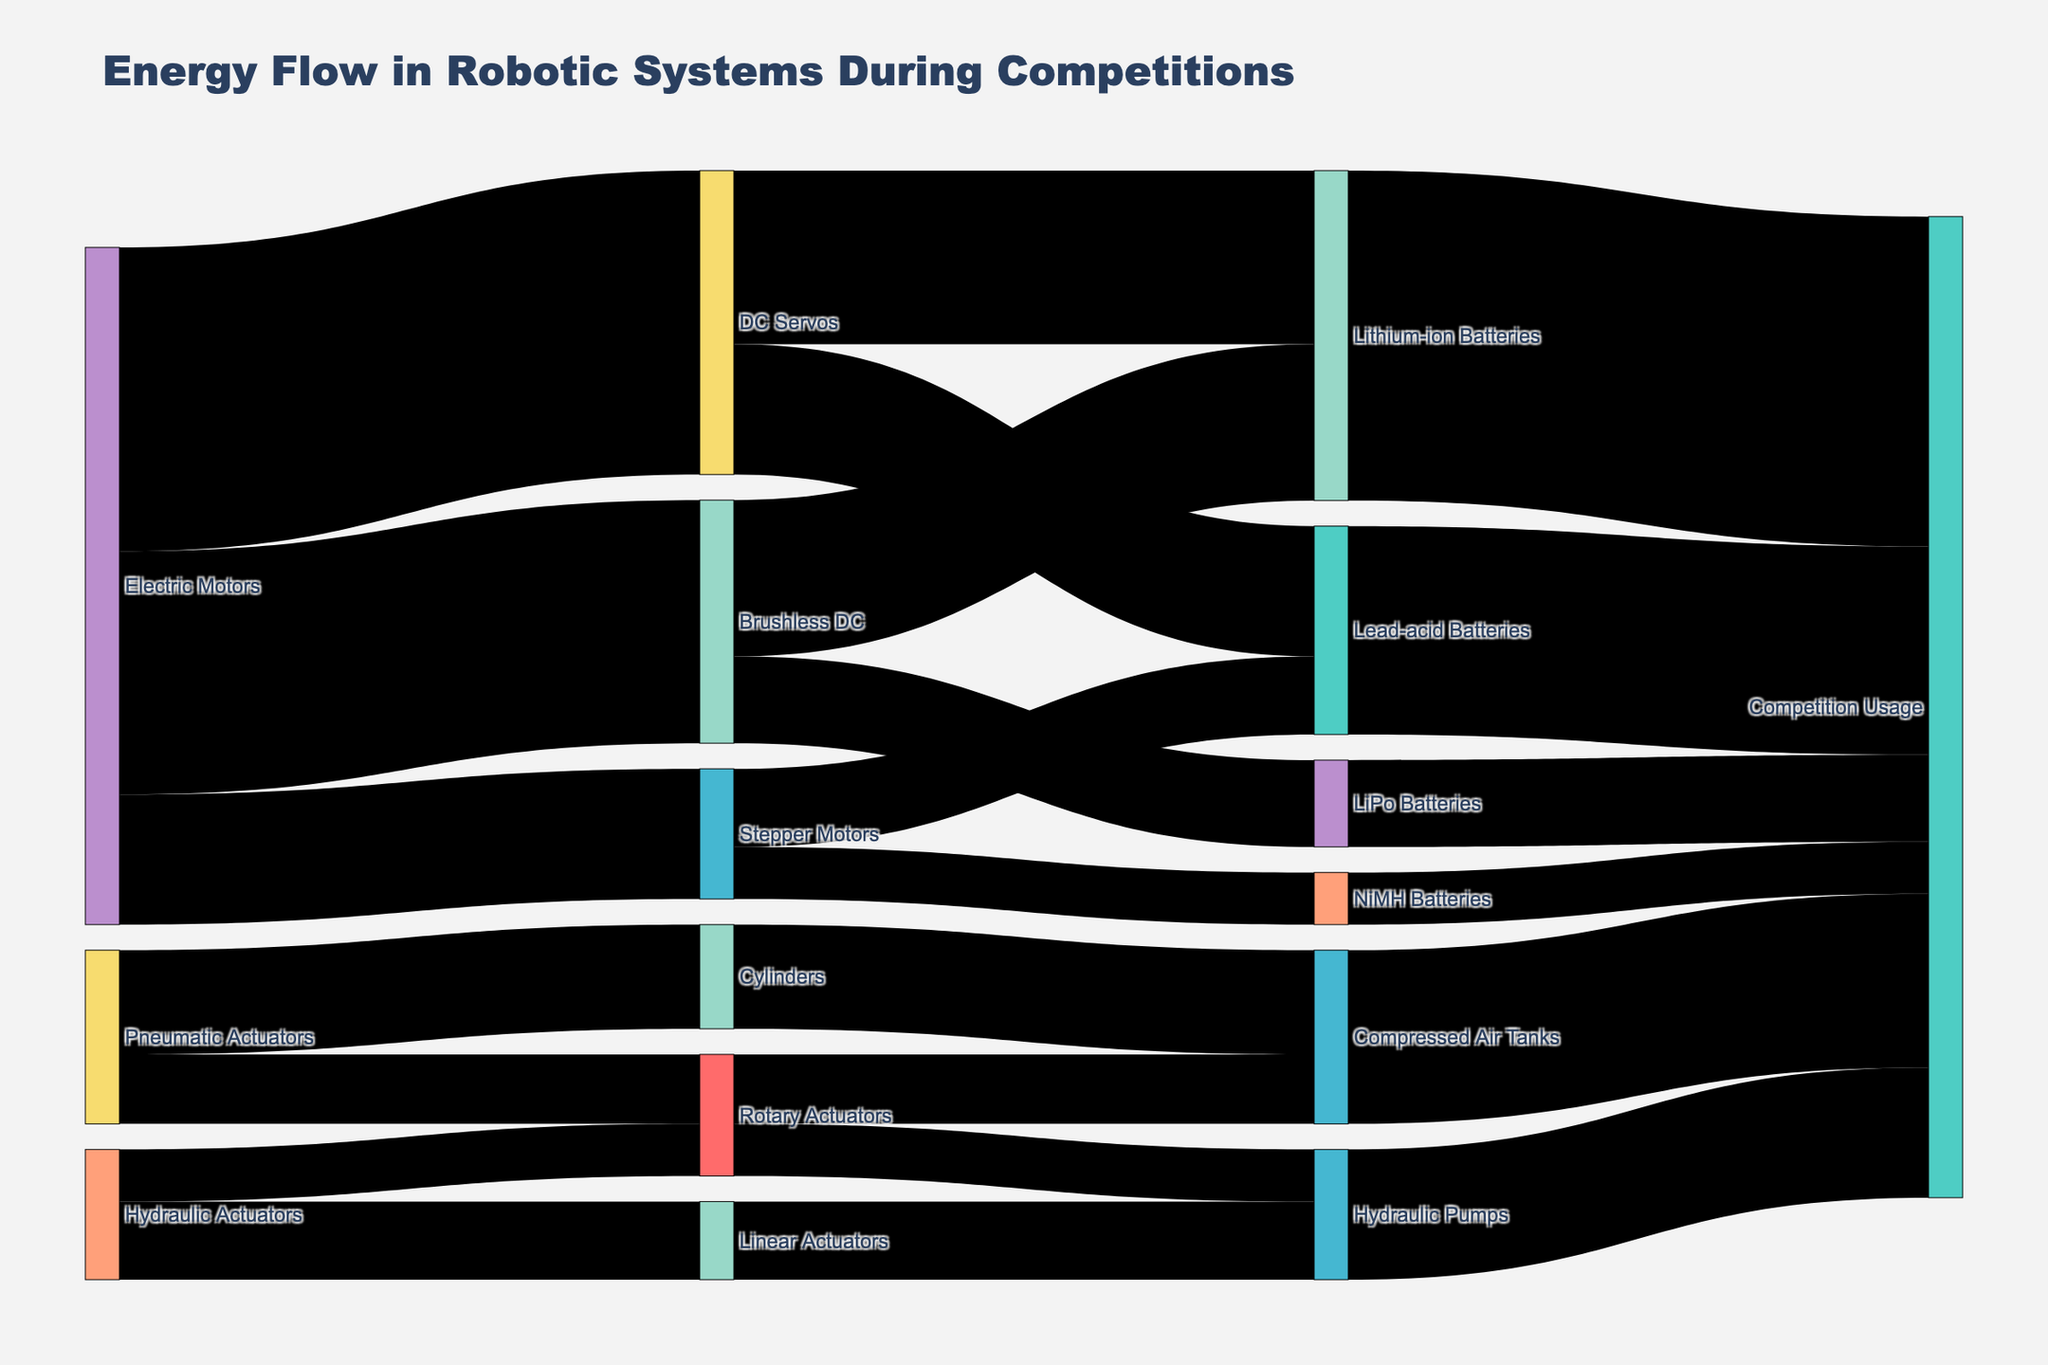what is the title of the figure? The title of the figure is found at the top of the diagram and describes the content. In this case, it reads, "Energy Flow in Robotic Systems During Competitions."
Answer: Energy Flow in Robotic Systems During Competitions which actuator consumes the highest energy from electric motors? You need to check the links starting from "Electric Motors" and find the link with the highest value. The highest value is 350 for "Electric Motors → DC Servos."
Answer: DC Servos how many categories of actuators are present in the system? By examining the distinct source nodes related to actuators, you can count them. The categories are "Electric Motors," "Pneumatic Actuators," and "Hydraulic Actuators."
Answer: 3 what is the total energy consumption by DC Servos, and how is it distributed among different power sources? To find the total, sum the values from "DC Servos" to its target nodes. The values are 200 (Lithium-ion Batteries) and 150 (Lead-acid Batteries), making the total 350.
Answer: 350, distributed as 200 (Lithium-ion Batteries) and 150 (Lead-acid Batteries) is the energy consumption by Rotary Actuators higher when powered by Pneumatic Actuators or Hydraulic Actuators? Examine the targets of "Rotary Actuators" from both "Pneumatic Actuators" and "Hydraulic Actuators." From Pneumatic Actuators, it's 80. From Hydraulic Actuators, it's 60. Comparing these, 80 is higher than 60.
Answer: Pneumatic Actuators which type of battery powers the most robotic systems in competitions? By examining the final links leading to "Competition Usage," identify the highest value among batteries. "Lithium-ion Batteries" have the highest value of 380.
Answer: Lithium-ion Batteries what is the total flow of energy usage from compressed air tanks in competitions? Check the value that links "Compressed Air Tanks" to "Competition Usage." This value is 200.
Answer: 200 how does the energy consumption of stepper motors from lead-acid batteries compare to NiMH batteries? Note the values flowing from "Stepper Motors" to each battery. Lead-acid Batteries have 90, and NiMH Batteries have 60. Comparing them, 90 is greater than 60.
Answer: Lead-acid Batteries calculate the total energy consumption by batteries in competitions. Sum the values of energy usage by all batteries. The values are 380 (Lithium-ion), 240 (Lead-acid), 100 (LiPo), and 60 (NiMH). The total is 380 + 240 + 100 + 60 = 780.
Answer: 780 